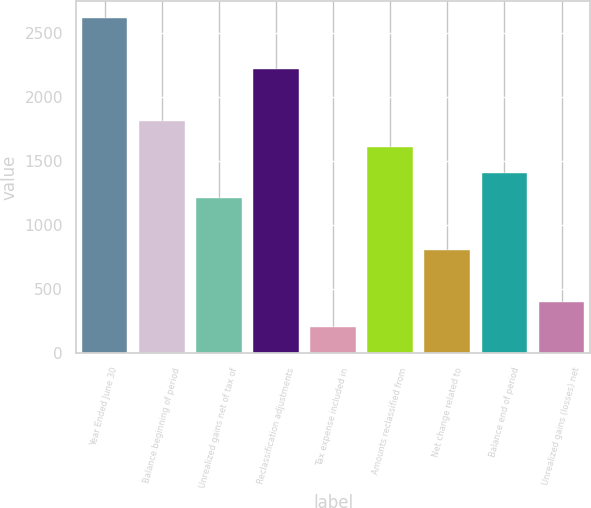Convert chart to OTSL. <chart><loc_0><loc_0><loc_500><loc_500><bar_chart><fcel>Year Ended June 30<fcel>Balance beginning of period<fcel>Unrealized gains net of tax of<fcel>Reclassification adjustments<fcel>Tax expense included in<fcel>Amounts reclassified from<fcel>Net change related to<fcel>Balance end of period<fcel>Unrealized gains (losses) net<nl><fcel>2620.66<fcel>1814.42<fcel>1209.74<fcel>2217.54<fcel>201.94<fcel>1612.86<fcel>806.62<fcel>1411.3<fcel>403.5<nl></chart> 